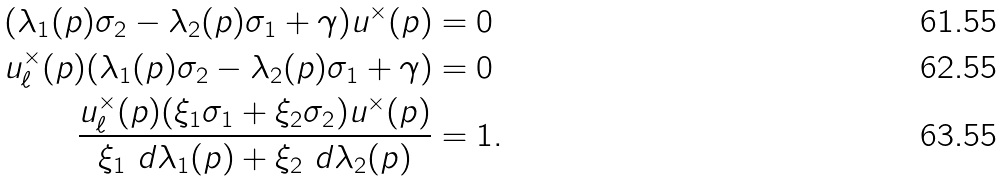Convert formula to latex. <formula><loc_0><loc_0><loc_500><loc_500>( \lambda _ { 1 } ( p ) \sigma _ { 2 } - \lambda _ { 2 } ( p ) \sigma _ { 1 } + \gamma ) u ^ { \times } ( p ) & = 0 \\ u _ { \ell } ^ { \times } ( p ) ( \lambda _ { 1 } ( p ) \sigma _ { 2 } - \lambda _ { 2 } ( p ) \sigma _ { 1 } + \gamma ) & = 0 \\ \frac { u _ { \ell } ^ { \times } ( p ) ( \xi _ { 1 } \sigma _ { 1 } + \xi _ { 2 } \sigma _ { 2 } ) u ^ { \times } ( p ) } { \xi _ { 1 } \ d \lambda _ { 1 } ( p ) + \xi _ { 2 } \ d \lambda _ { 2 } ( p ) } & = 1 .</formula> 